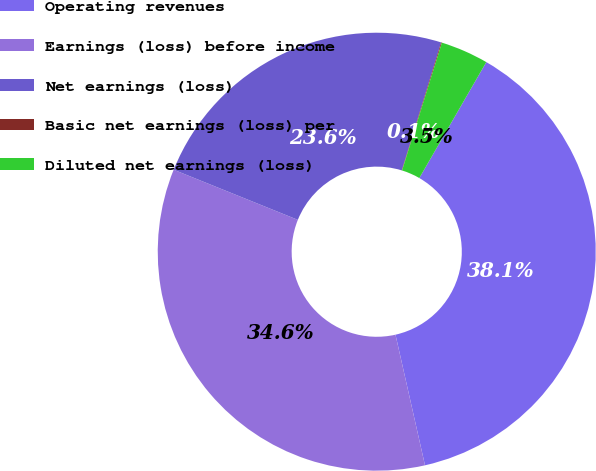Convert chart. <chart><loc_0><loc_0><loc_500><loc_500><pie_chart><fcel>Operating revenues<fcel>Earnings (loss) before income<fcel>Net earnings (loss)<fcel>Basic net earnings (loss) per<fcel>Diluted net earnings (loss)<nl><fcel>38.12%<fcel>34.64%<fcel>23.64%<fcel>0.06%<fcel>3.53%<nl></chart> 